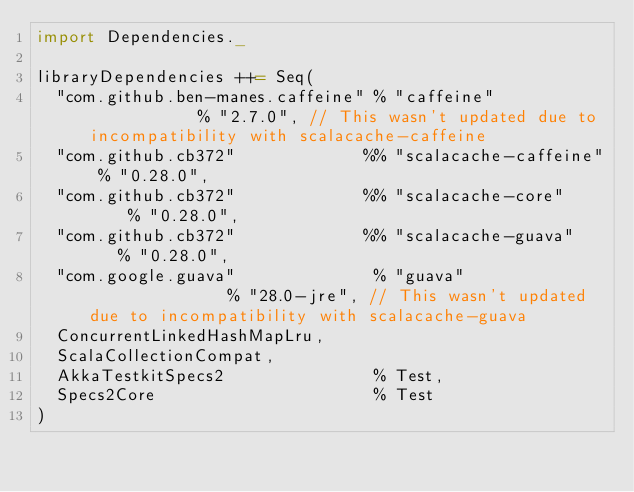Convert code to text. <code><loc_0><loc_0><loc_500><loc_500><_Scala_>import Dependencies._

libraryDependencies ++= Seq(
  "com.github.ben-manes.caffeine" % "caffeine"            % "2.7.0", // This wasn't updated due to incompatibility with scalacache-caffeine
  "com.github.cb372"             %% "scalacache-caffeine" % "0.28.0",
  "com.github.cb372"             %% "scalacache-core"     % "0.28.0",
  "com.github.cb372"             %% "scalacache-guava"    % "0.28.0",
  "com.google.guava"              % "guava"               % "28.0-jre", // This wasn't updated due to incompatibility with scalacache-guava
  ConcurrentLinkedHashMapLru,
  ScalaCollectionCompat,
  AkkaTestkitSpecs2               % Test,
  Specs2Core                      % Test
)
</code> 